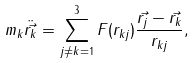<formula> <loc_0><loc_0><loc_500><loc_500>m _ { k } \ddot { \vec { r _ { k } } } = \sum _ { j \neq k = 1 } ^ { 3 } F ( r _ { k j } ) \frac { \vec { r _ { j } } - \vec { r _ { k } } } { r _ { k j } } ,</formula> 